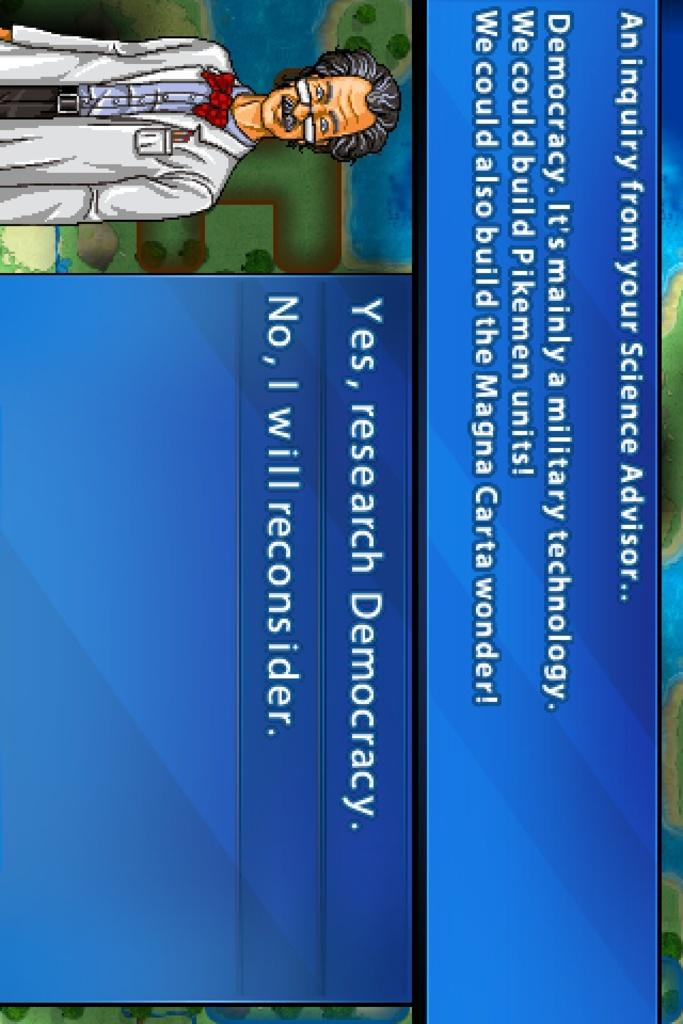<image>
Present a compact description of the photo's key features. a game with a option to say Yes to Democracy research 